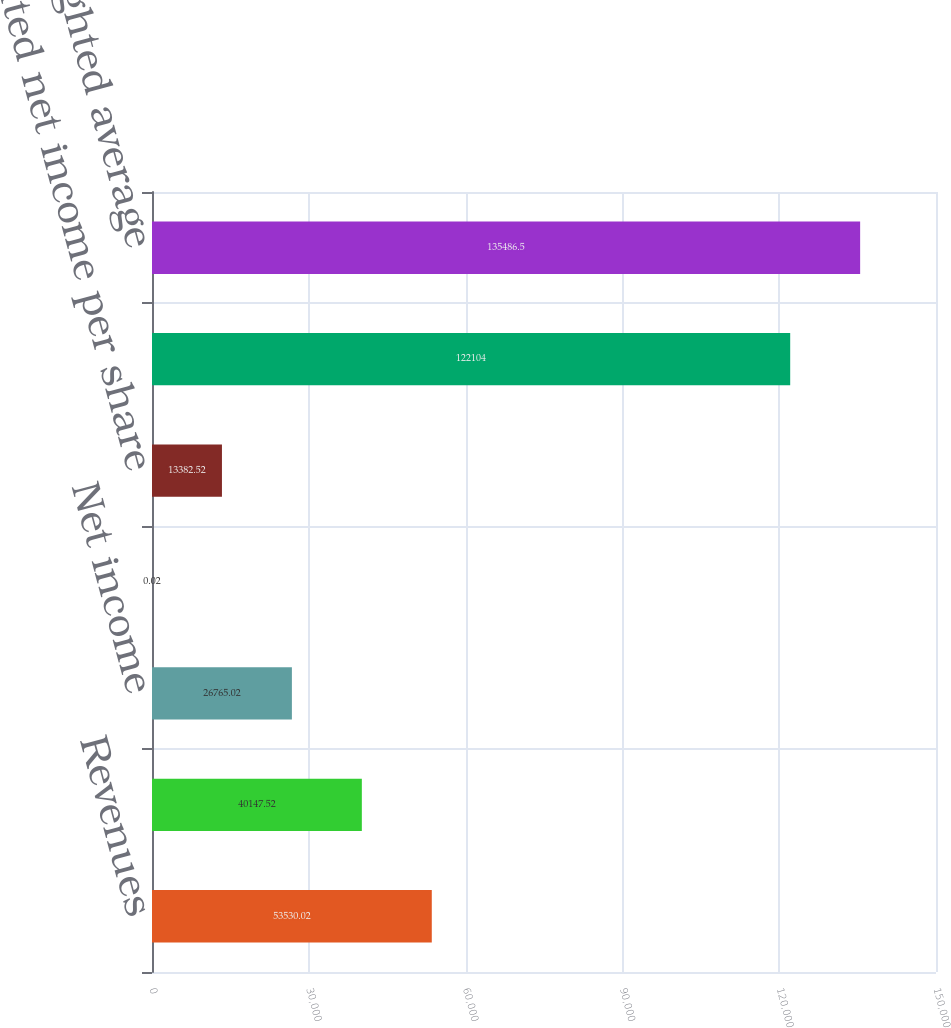Convert chart. <chart><loc_0><loc_0><loc_500><loc_500><bar_chart><fcel>Revenues<fcel>Cost of revenues<fcel>Net income<fcel>Basic net income per share<fcel>Diluted net income per share<fcel>Basic weighted average common<fcel>Diluted weighted average<nl><fcel>53530<fcel>40147.5<fcel>26765<fcel>0.02<fcel>13382.5<fcel>122104<fcel>135486<nl></chart> 